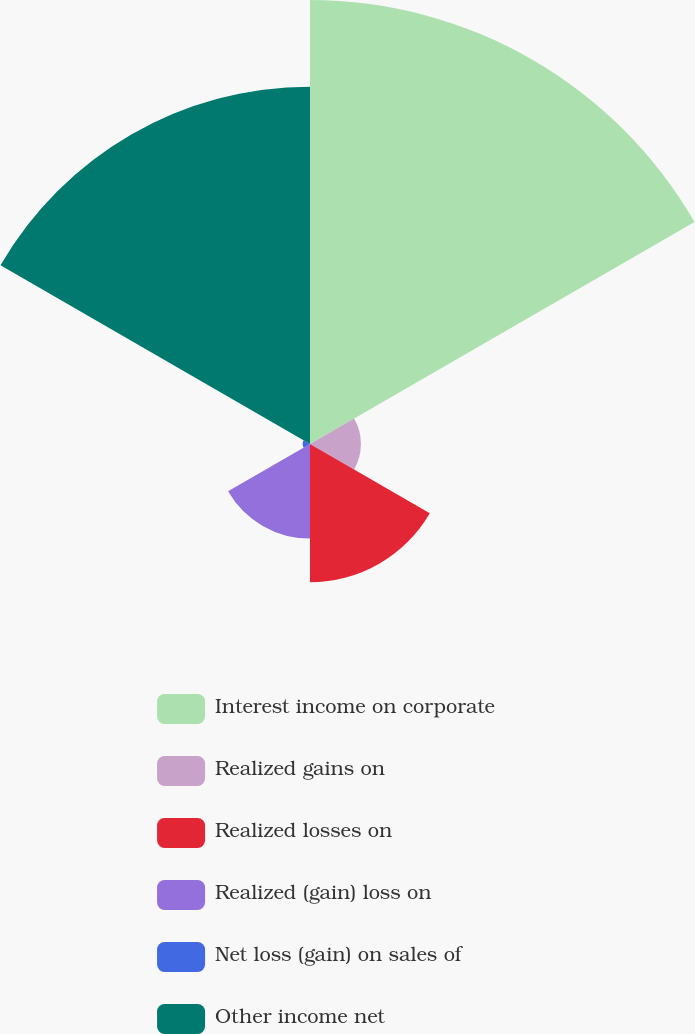<chart> <loc_0><loc_0><loc_500><loc_500><pie_chart><fcel>Interest income on corporate<fcel>Realized gains on<fcel>Realized losses on<fcel>Realized (gain) loss on<fcel>Net loss (gain) on sales of<fcel>Other income net<nl><fcel>40.64%<fcel>4.66%<fcel>12.66%<fcel>8.66%<fcel>0.67%<fcel>32.71%<nl></chart> 